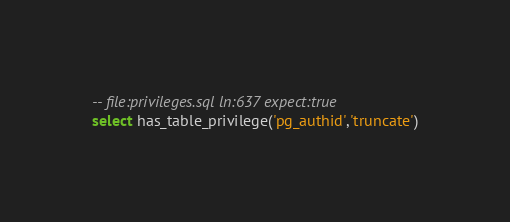<code> <loc_0><loc_0><loc_500><loc_500><_SQL_>-- file:privileges.sql ln:637 expect:true
select has_table_privilege('pg_authid','truncate')
</code> 